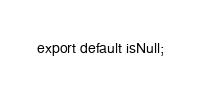<code> <loc_0><loc_0><loc_500><loc_500><_JavaScript_>
export default isNull;
</code> 